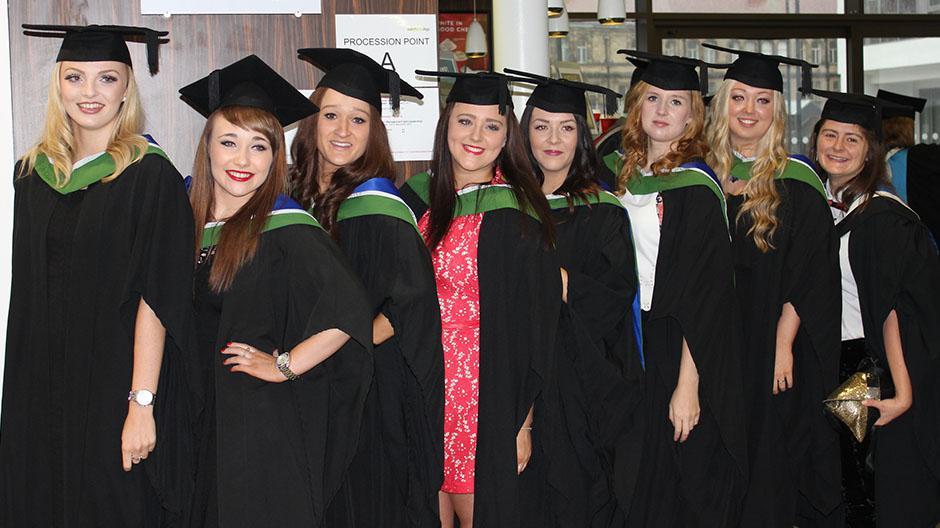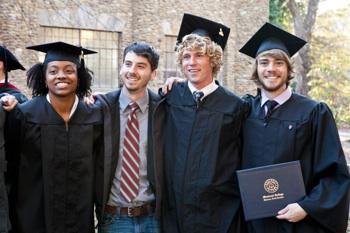The first image is the image on the left, the second image is the image on the right. Given the left and right images, does the statement "An image includes three blond girls in graduation garb, posed side-by-side in a straight row." hold true? Answer yes or no. No. The first image is the image on the left, the second image is the image on the right. For the images displayed, is the sentence "There are only women in the left image, but both men and women on the right." factually correct? Answer yes or no. Yes. 